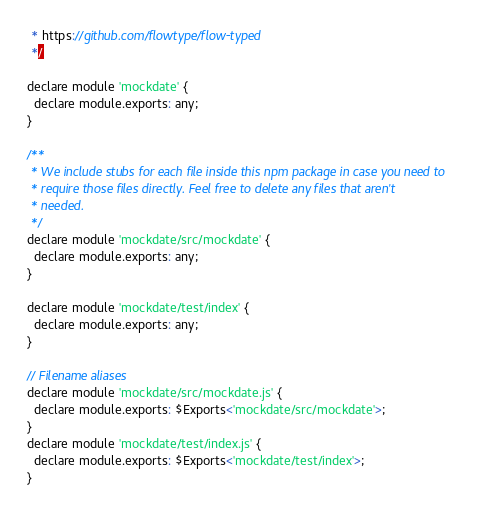Convert code to text. <code><loc_0><loc_0><loc_500><loc_500><_JavaScript_> * https://github.com/flowtype/flow-typed
 */

declare module 'mockdate' {
  declare module.exports: any;
}

/**
 * We include stubs for each file inside this npm package in case you need to
 * require those files directly. Feel free to delete any files that aren't
 * needed.
 */
declare module 'mockdate/src/mockdate' {
  declare module.exports: any;
}

declare module 'mockdate/test/index' {
  declare module.exports: any;
}

// Filename aliases
declare module 'mockdate/src/mockdate.js' {
  declare module.exports: $Exports<'mockdate/src/mockdate'>;
}
declare module 'mockdate/test/index.js' {
  declare module.exports: $Exports<'mockdate/test/index'>;
}
</code> 